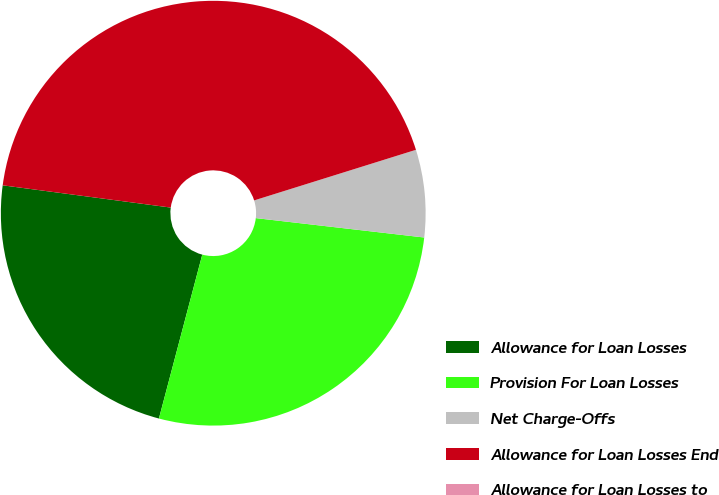Convert chart to OTSL. <chart><loc_0><loc_0><loc_500><loc_500><pie_chart><fcel>Allowance for Loan Losses<fcel>Provision For Loan Losses<fcel>Net Charge-Offs<fcel>Allowance for Loan Losses End<fcel>Allowance for Loan Losses to<nl><fcel>22.98%<fcel>27.29%<fcel>6.65%<fcel>43.08%<fcel>0.0%<nl></chart> 